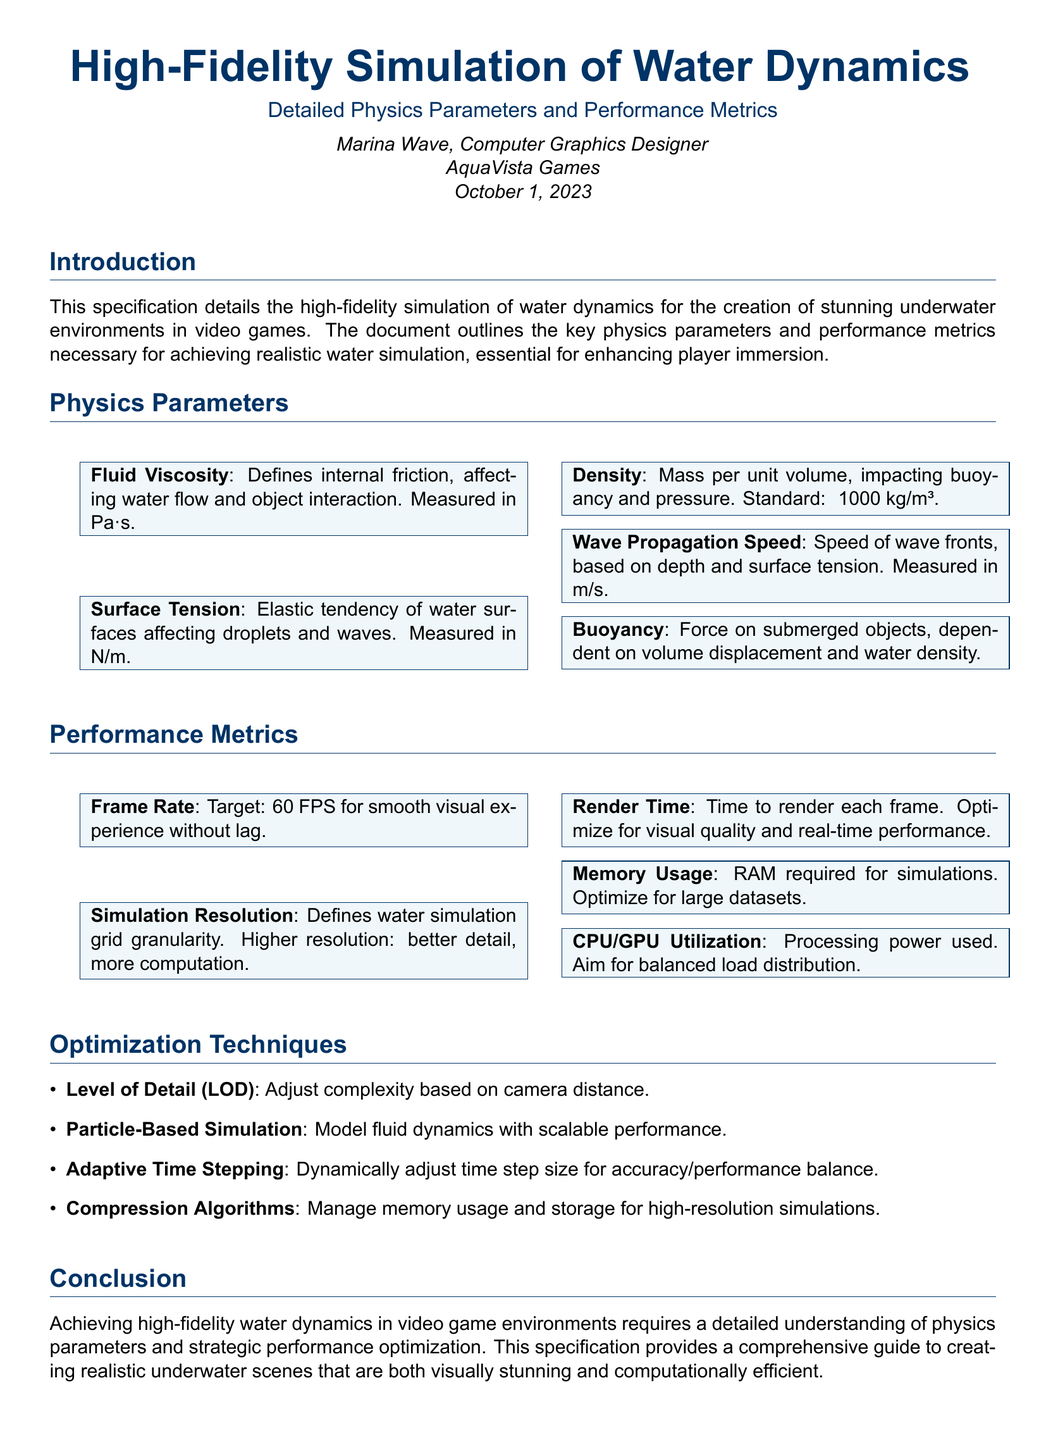what is the standard density of water mentioned? The standard density of water is stated as approximately 1000 kg/m³ in the document.
Answer: 1000 kg/m³ what is the target frame rate for smooth visual experience? The document specifies that the target frame rate is 60 FPS to ensure a smooth visual experience without lag.
Answer: 60 FPS what does the fluid viscosity parameter influence? The fluid viscosity parameter defines internal friction, which affects both water flow and interaction with objects in the simulation.
Answer: water flow and object interaction what is the purpose of Level of Detail (LOD) in optimization techniques? Level of Detail (LOD) is used to adjust the complexity of rendering based on how far the camera is from objects, enhancing performance.
Answer: adjust complexity based on camera distance how is buoyancy described in the document? Buoyancy in the document is described as the force acting on submerged objects, which is dependent on volume displacement and water density.
Answer: force on submerged objects what is the significance of simulation resolution? The simulation resolution defines the grid granularity for water simulations, where higher resolution yields better detail but requires more computational power.
Answer: grid granularity how does the document define surface tension? Surface tension is defined as the elastic tendency of water surfaces, impacting droplets and wave behaviors in the simulation.
Answer: elastic tendency of water surfaces what optimization technique helps manage memory usage? The document mentions compression algorithms as techniques that help manage memory usage and storage for high-resolution simulations.
Answer: compression algorithms 